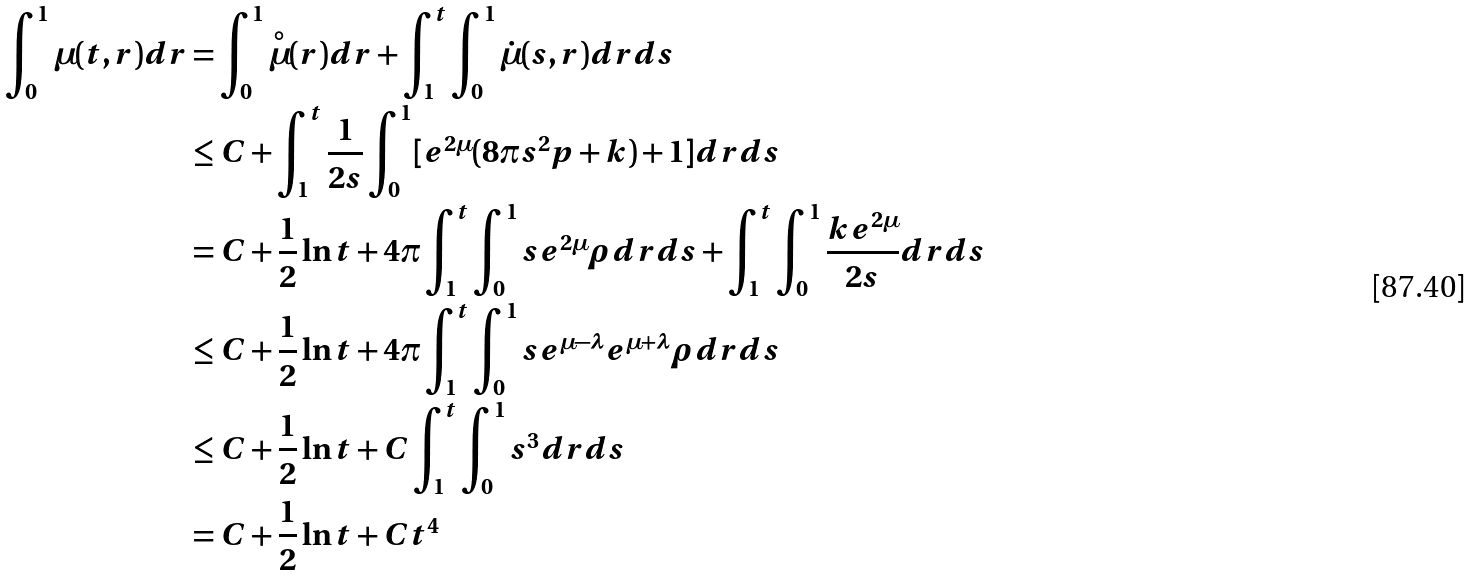Convert formula to latex. <formula><loc_0><loc_0><loc_500><loc_500>\int _ { 0 } ^ { 1 } \mu ( t , r ) d r & = \int _ { 0 } ^ { 1 } \overset { \circ } { \mu } ( r ) d r + \int _ { 1 } ^ { t } \int _ { 0 } ^ { 1 } \dot { \mu } ( s , r ) d r d s \\ & \leq C + \int _ { 1 } ^ { t } \frac { 1 } { 2 s } \int _ { 0 } ^ { 1 } [ e ^ { 2 \mu } ( 8 \pi s ^ { 2 } p + k ) + 1 ] d r d s \\ & = C + \frac { 1 } { 2 } \ln t + 4 \pi \int _ { 1 } ^ { t } \int _ { 0 } ^ { 1 } s e ^ { 2 \mu } \rho d r d s + \int _ { 1 } ^ { t } \int _ { 0 } ^ { 1 } \frac { k e ^ { 2 \mu } } { 2 s } d r d s \\ & \leq C + \frac { 1 } { 2 } \ln t + 4 \pi \int _ { 1 } ^ { t } \int _ { 0 } ^ { 1 } s e ^ { \mu - \lambda } e ^ { \mu + \lambda } \rho d r d s \\ & \leq C + \frac { 1 } { 2 } \ln t + C \int _ { 1 } ^ { t } \int _ { 0 } ^ { 1 } s ^ { 3 } d r d s \\ & = C + \frac { 1 } { 2 } \ln t + C t ^ { 4 }</formula> 